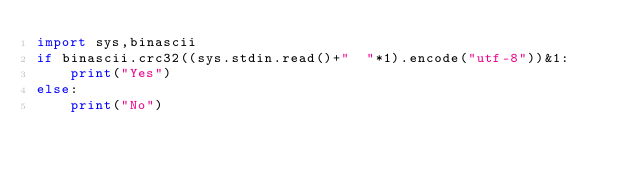Convert code to text. <code><loc_0><loc_0><loc_500><loc_500><_Python_>import sys,binascii
if binascii.crc32((sys.stdin.read()+"  "*1).encode("utf-8"))&1:
    print("Yes")  
else:
    print("No")</code> 